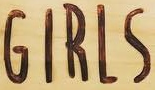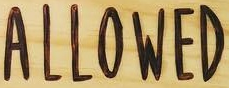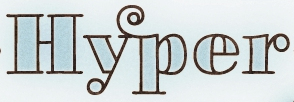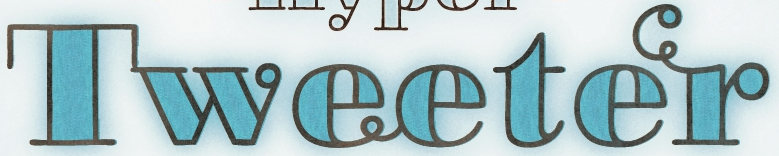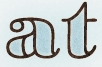What words are shown in these images in order, separated by a semicolon? GIRLS; ALLOWED; Hyper; Tweeter; at 